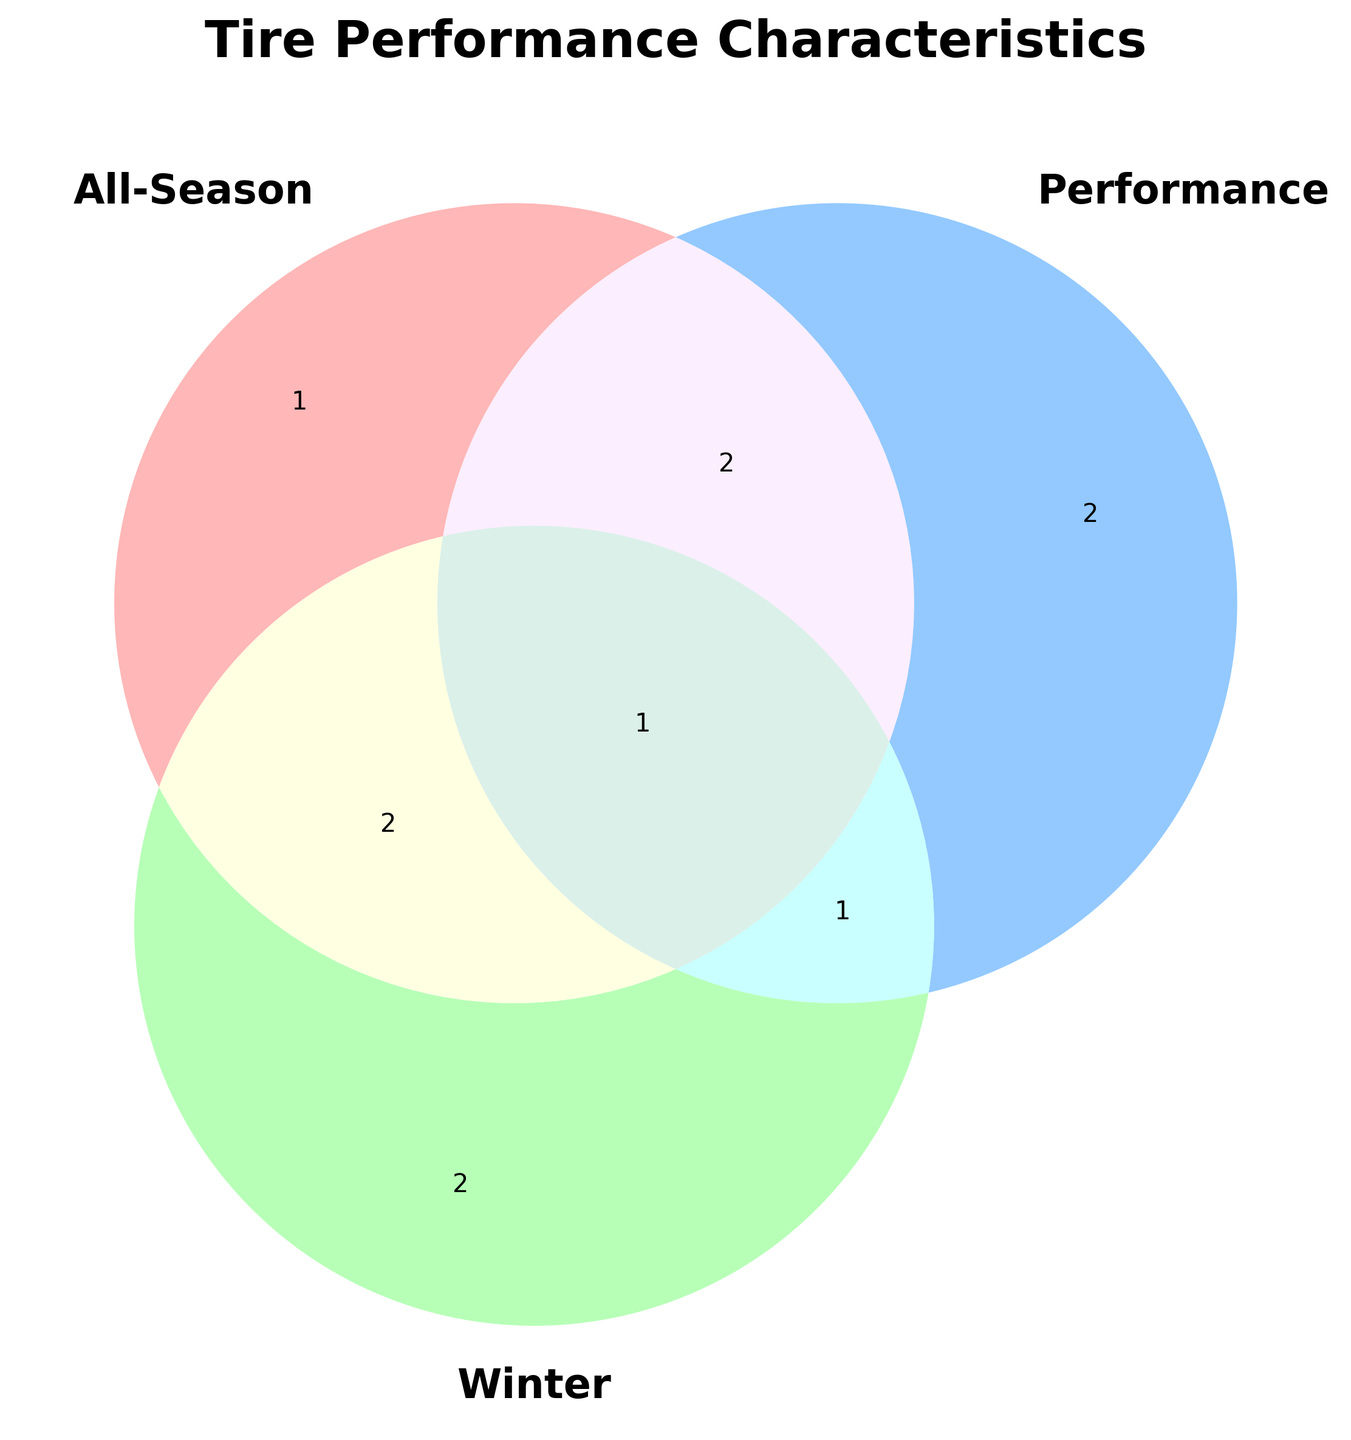What is the main title of the Venn diagram? The title is prominently displayed at the top of the figure and summarizes the main content of the diagram.
Answer: Tire Performance Characteristics Which color represents the 'All-Season' category in the Venn diagram? By examining the color-coded sections of the Venn diagram, we identify the color belonging to the 'All-Season' section.
Answer: #FF9999 What are two characteristics exclusive to the 'Performance' category? The exclusive characteristics of the 'Performance' category are located in the section of the Venn diagram that only overlaps with 'Performance'.
Answer: Cornering Grip, High-Speed Stability What characteristic is shared by 'All-Season' and 'Performance' but not by 'Winter'? This characteristic is found in the intersection of 'All-Season' and 'Performance' that does not overlap with 'Winter'.
Answer: Handling Response How many characteristics are shared among all three categories? The total number of shared characteristics is located at the center of the Venn diagram where all three sets intersect.
Answer: 1 Which category has the largest number of unique characteristics? By comparing the sizes of the areas that do not overlap with any other category, we determine which has the most unique characteristics.
Answer: All-Season Is 'Wet Traction' a characteristic found in all three categories? We locate 'Wet Traction' and identify whether it appears in the middle section of all three intersecting sets.
Answer: No What characteristic is shared by 'All-Season' and 'Winter' categories? We look at the area where 'All-Season' and 'Winter' sections overlap without including 'Performance'.
Answer: Aquaplaning Resistance Which categories recognize 'Temperature Sensitivity' as a characteristic? We find the sections that 'Temperature Sensitivity' appears in, noting each category involved in this shared property.
Answer: Performance, Winter Identify one characteristic that is only found in the 'Winter' category and not shared with others. This is located in the section of the Venn diagram where only 'Winter' characteristics are indicated.
Answer: Snow Traction 